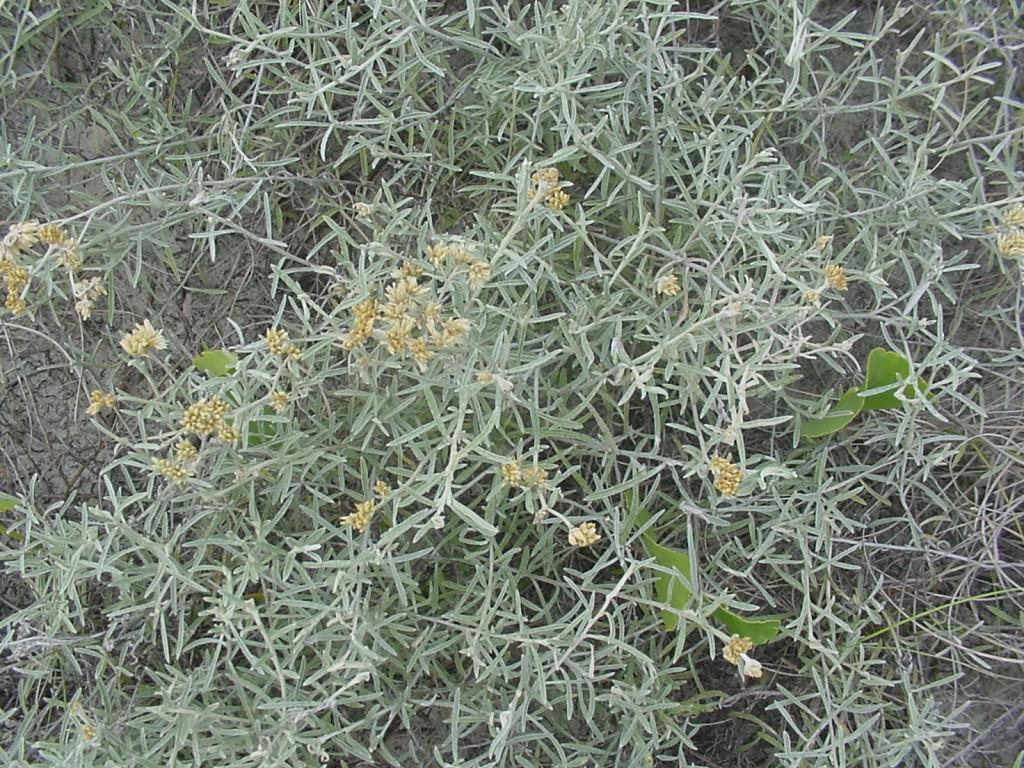What type of surface is visible in the image? There is ground visible in the image. What type of vegetation can be seen in the image? There are plants and flowers in the image. What type of wire can be seen connecting the flowers in the image? There is no wire connecting the flowers in the image; the flowers are not connected by any visible wires. 